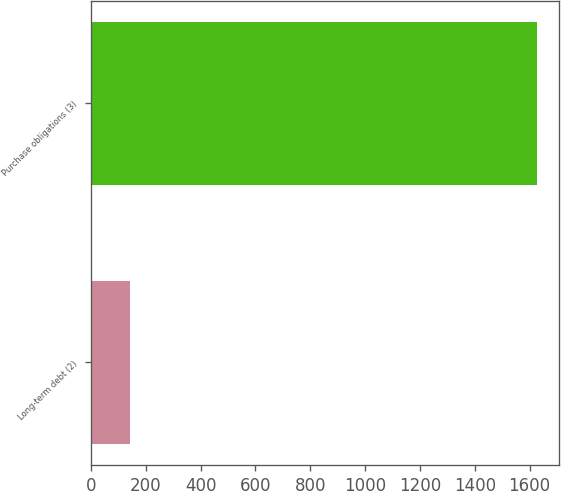Convert chart. <chart><loc_0><loc_0><loc_500><loc_500><bar_chart><fcel>Long-term debt (2)<fcel>Purchase obligations (3)<nl><fcel>143<fcel>1627<nl></chart> 